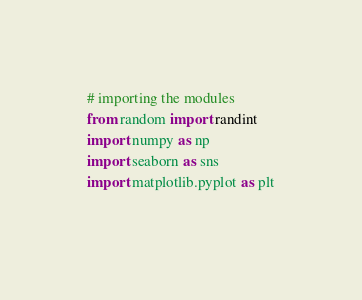<code> <loc_0><loc_0><loc_500><loc_500><_Python_># importing the modules
from random import randint
import numpy as np
import seaborn as sns
import matplotlib.pyplot as plt
  </code> 